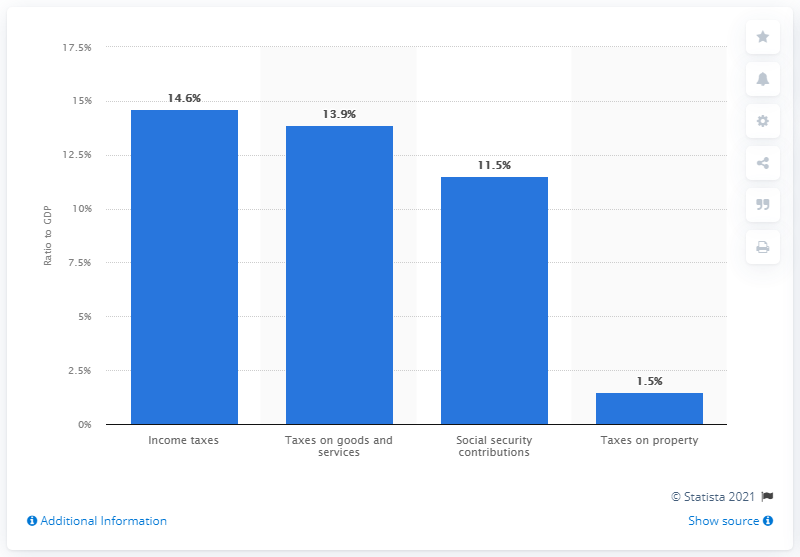List a handful of essential elements in this visual. In 2020, social security contributions accounted for approximately 11.5% of Finland's Gross Domestic Product (GDP). 